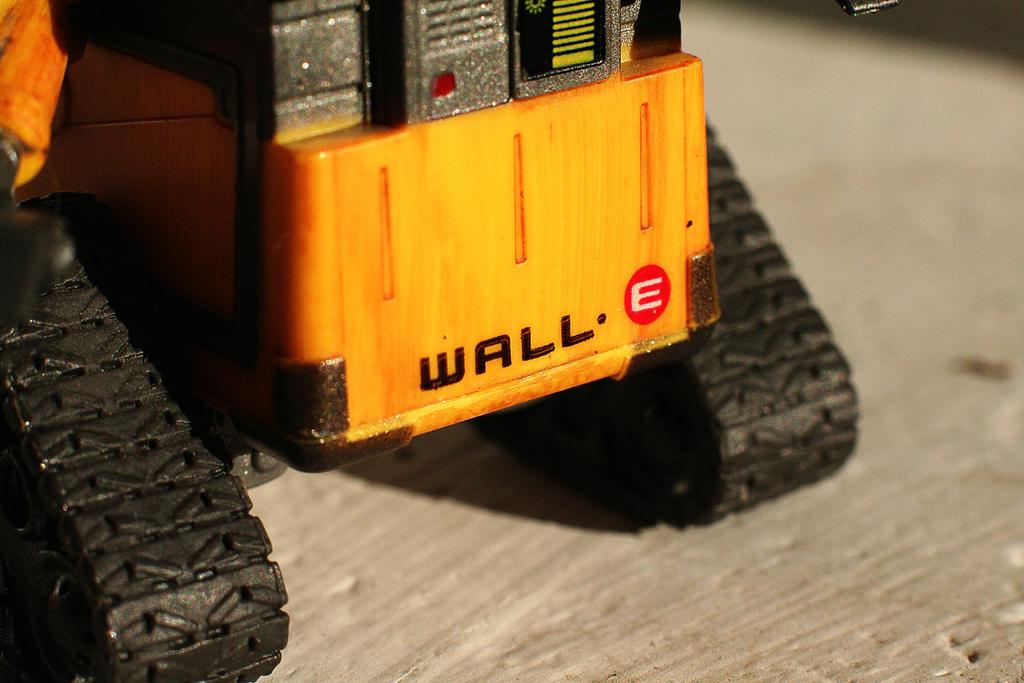What type of toy is present in the image? There is a toy vehicle in the image. Can you describe the position of the toy vehicle in the image? The toy vehicle is on a surface. What type of pear is being used to make a statement in the image? There is no pear present in the image, and no statement is being made by a pear. 